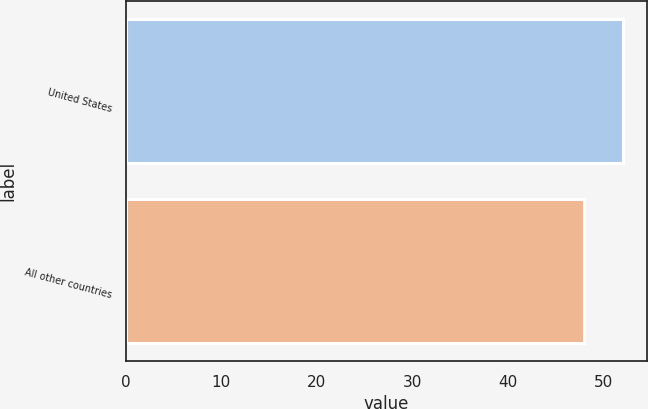<chart> <loc_0><loc_0><loc_500><loc_500><bar_chart><fcel>United States<fcel>All other countries<nl><fcel>52<fcel>48<nl></chart> 